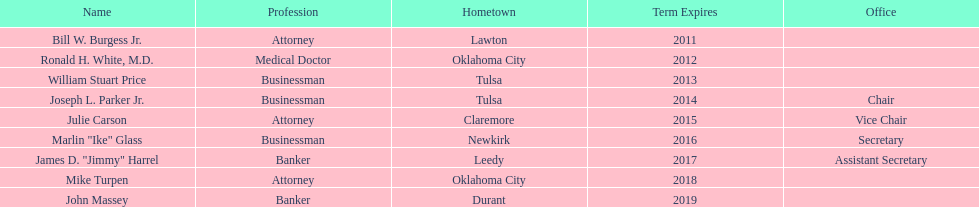Total number of members from lawton and oklahoma city 3. Parse the full table. {'header': ['Name', 'Profession', 'Hometown', 'Term Expires', 'Office'], 'rows': [['Bill W. Burgess Jr.', 'Attorney', 'Lawton', '2011', ''], ['Ronald H. White, M.D.', 'Medical Doctor', 'Oklahoma City', '2012', ''], ['William Stuart Price', 'Businessman', 'Tulsa', '2013', ''], ['Joseph L. Parker Jr.', 'Businessman', 'Tulsa', '2014', 'Chair'], ['Julie Carson', 'Attorney', 'Claremore', '2015', 'Vice Chair'], ['Marlin "Ike" Glass', 'Businessman', 'Newkirk', '2016', 'Secretary'], ['James D. "Jimmy" Harrel', 'Banker', 'Leedy', '2017', 'Assistant Secretary'], ['Mike Turpen', 'Attorney', 'Oklahoma City', '2018', ''], ['John Massey', 'Banker', 'Durant', '2019', '']]} 